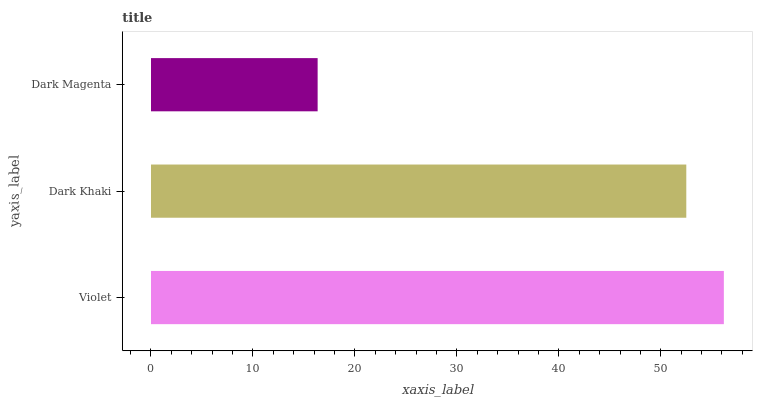Is Dark Magenta the minimum?
Answer yes or no. Yes. Is Violet the maximum?
Answer yes or no. Yes. Is Dark Khaki the minimum?
Answer yes or no. No. Is Dark Khaki the maximum?
Answer yes or no. No. Is Violet greater than Dark Khaki?
Answer yes or no. Yes. Is Dark Khaki less than Violet?
Answer yes or no. Yes. Is Dark Khaki greater than Violet?
Answer yes or no. No. Is Violet less than Dark Khaki?
Answer yes or no. No. Is Dark Khaki the high median?
Answer yes or no. Yes. Is Dark Khaki the low median?
Answer yes or no. Yes. Is Dark Magenta the high median?
Answer yes or no. No. Is Dark Magenta the low median?
Answer yes or no. No. 